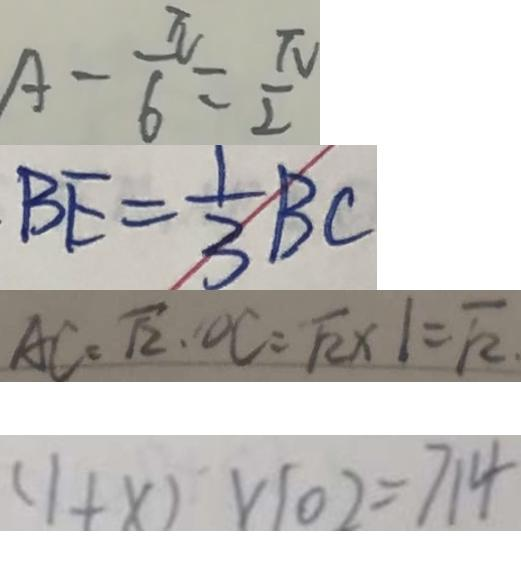<formula> <loc_0><loc_0><loc_500><loc_500>A - \frac { \pi } { 6 } = \frac { \pi } { 2 } 
 B E = \frac { 1 } { 3 } B C 
 A C = \sqrt { 2 } \cdot O C = \sqrt { 2 } \times 1 = \sqrt { 2 } . 
 ( 1 + x ) \times 1 0 2 = 7 1 4</formula> 